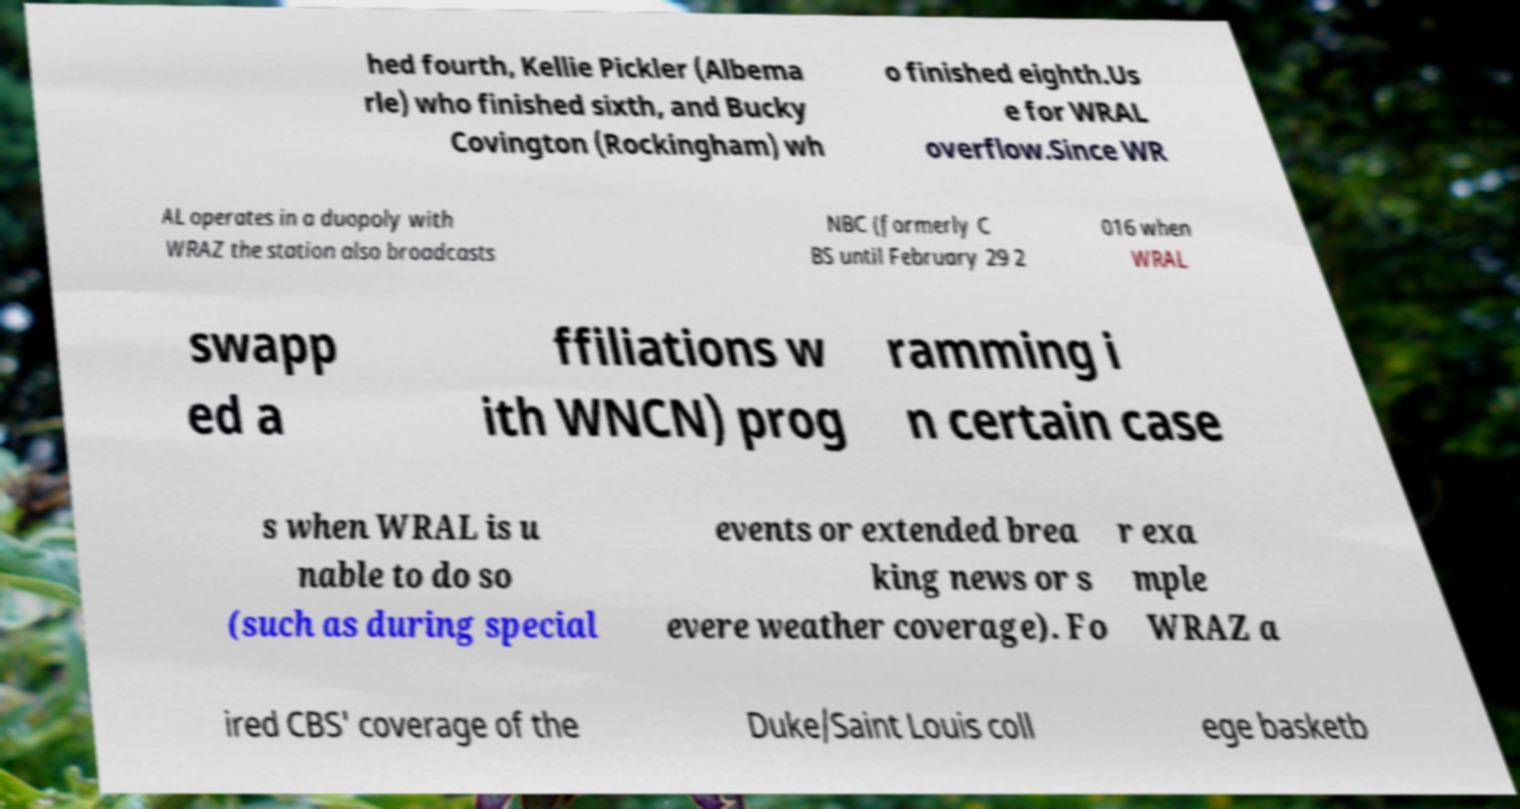For documentation purposes, I need the text within this image transcribed. Could you provide that? hed fourth, Kellie Pickler (Albema rle) who finished sixth, and Bucky Covington (Rockingham) wh o finished eighth.Us e for WRAL overflow.Since WR AL operates in a duopoly with WRAZ the station also broadcasts NBC (formerly C BS until February 29 2 016 when WRAL swapp ed a ffiliations w ith WNCN) prog ramming i n certain case s when WRAL is u nable to do so (such as during special events or extended brea king news or s evere weather coverage). Fo r exa mple WRAZ a ired CBS' coverage of the Duke/Saint Louis coll ege basketb 